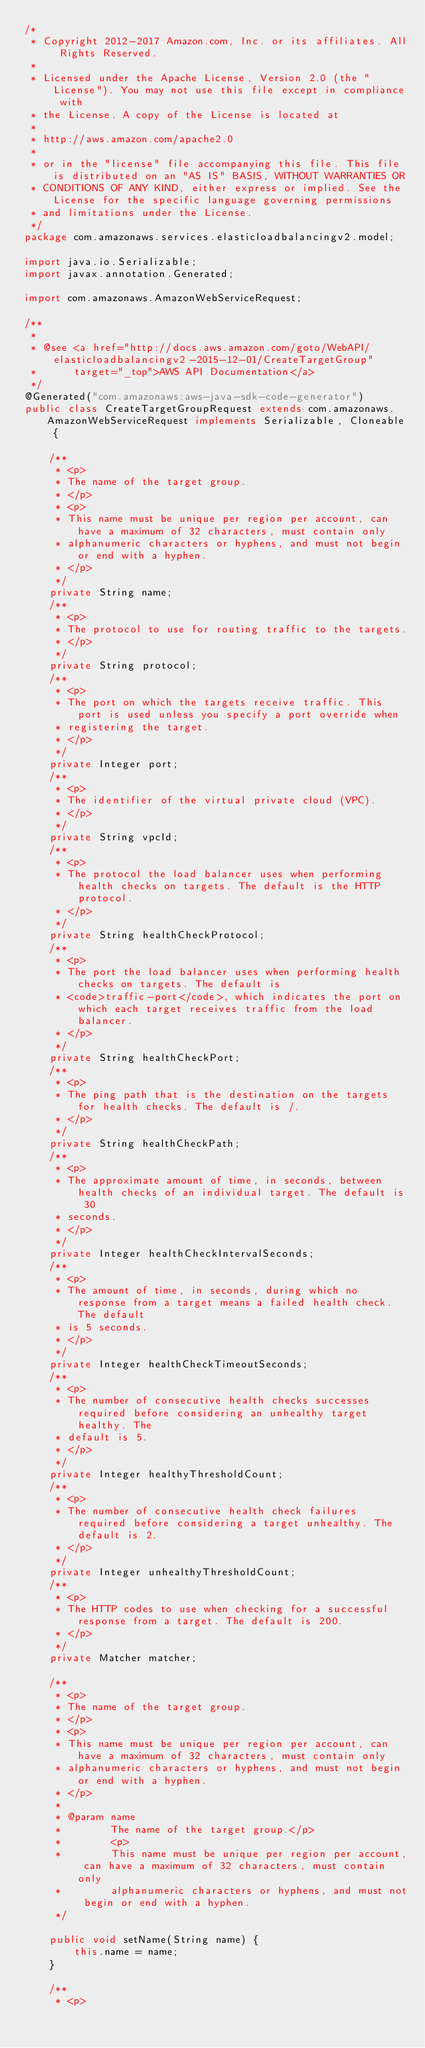Convert code to text. <code><loc_0><loc_0><loc_500><loc_500><_Java_>/*
 * Copyright 2012-2017 Amazon.com, Inc. or its affiliates. All Rights Reserved.
 * 
 * Licensed under the Apache License, Version 2.0 (the "License"). You may not use this file except in compliance with
 * the License. A copy of the License is located at
 * 
 * http://aws.amazon.com/apache2.0
 * 
 * or in the "license" file accompanying this file. This file is distributed on an "AS IS" BASIS, WITHOUT WARRANTIES OR
 * CONDITIONS OF ANY KIND, either express or implied. See the License for the specific language governing permissions
 * and limitations under the License.
 */
package com.amazonaws.services.elasticloadbalancingv2.model;

import java.io.Serializable;
import javax.annotation.Generated;

import com.amazonaws.AmazonWebServiceRequest;

/**
 * 
 * @see <a href="http://docs.aws.amazon.com/goto/WebAPI/elasticloadbalancingv2-2015-12-01/CreateTargetGroup"
 *      target="_top">AWS API Documentation</a>
 */
@Generated("com.amazonaws:aws-java-sdk-code-generator")
public class CreateTargetGroupRequest extends com.amazonaws.AmazonWebServiceRequest implements Serializable, Cloneable {

    /**
     * <p>
     * The name of the target group.
     * </p>
     * <p>
     * This name must be unique per region per account, can have a maximum of 32 characters, must contain only
     * alphanumeric characters or hyphens, and must not begin or end with a hyphen.
     * </p>
     */
    private String name;
    /**
     * <p>
     * The protocol to use for routing traffic to the targets.
     * </p>
     */
    private String protocol;
    /**
     * <p>
     * The port on which the targets receive traffic. This port is used unless you specify a port override when
     * registering the target.
     * </p>
     */
    private Integer port;
    /**
     * <p>
     * The identifier of the virtual private cloud (VPC).
     * </p>
     */
    private String vpcId;
    /**
     * <p>
     * The protocol the load balancer uses when performing health checks on targets. The default is the HTTP protocol.
     * </p>
     */
    private String healthCheckProtocol;
    /**
     * <p>
     * The port the load balancer uses when performing health checks on targets. The default is
     * <code>traffic-port</code>, which indicates the port on which each target receives traffic from the load balancer.
     * </p>
     */
    private String healthCheckPort;
    /**
     * <p>
     * The ping path that is the destination on the targets for health checks. The default is /.
     * </p>
     */
    private String healthCheckPath;
    /**
     * <p>
     * The approximate amount of time, in seconds, between health checks of an individual target. The default is 30
     * seconds.
     * </p>
     */
    private Integer healthCheckIntervalSeconds;
    /**
     * <p>
     * The amount of time, in seconds, during which no response from a target means a failed health check. The default
     * is 5 seconds.
     * </p>
     */
    private Integer healthCheckTimeoutSeconds;
    /**
     * <p>
     * The number of consecutive health checks successes required before considering an unhealthy target healthy. The
     * default is 5.
     * </p>
     */
    private Integer healthyThresholdCount;
    /**
     * <p>
     * The number of consecutive health check failures required before considering a target unhealthy. The default is 2.
     * </p>
     */
    private Integer unhealthyThresholdCount;
    /**
     * <p>
     * The HTTP codes to use when checking for a successful response from a target. The default is 200.
     * </p>
     */
    private Matcher matcher;

    /**
     * <p>
     * The name of the target group.
     * </p>
     * <p>
     * This name must be unique per region per account, can have a maximum of 32 characters, must contain only
     * alphanumeric characters or hyphens, and must not begin or end with a hyphen.
     * </p>
     * 
     * @param name
     *        The name of the target group.</p>
     *        <p>
     *        This name must be unique per region per account, can have a maximum of 32 characters, must contain only
     *        alphanumeric characters or hyphens, and must not begin or end with a hyphen.
     */

    public void setName(String name) {
        this.name = name;
    }

    /**
     * <p></code> 